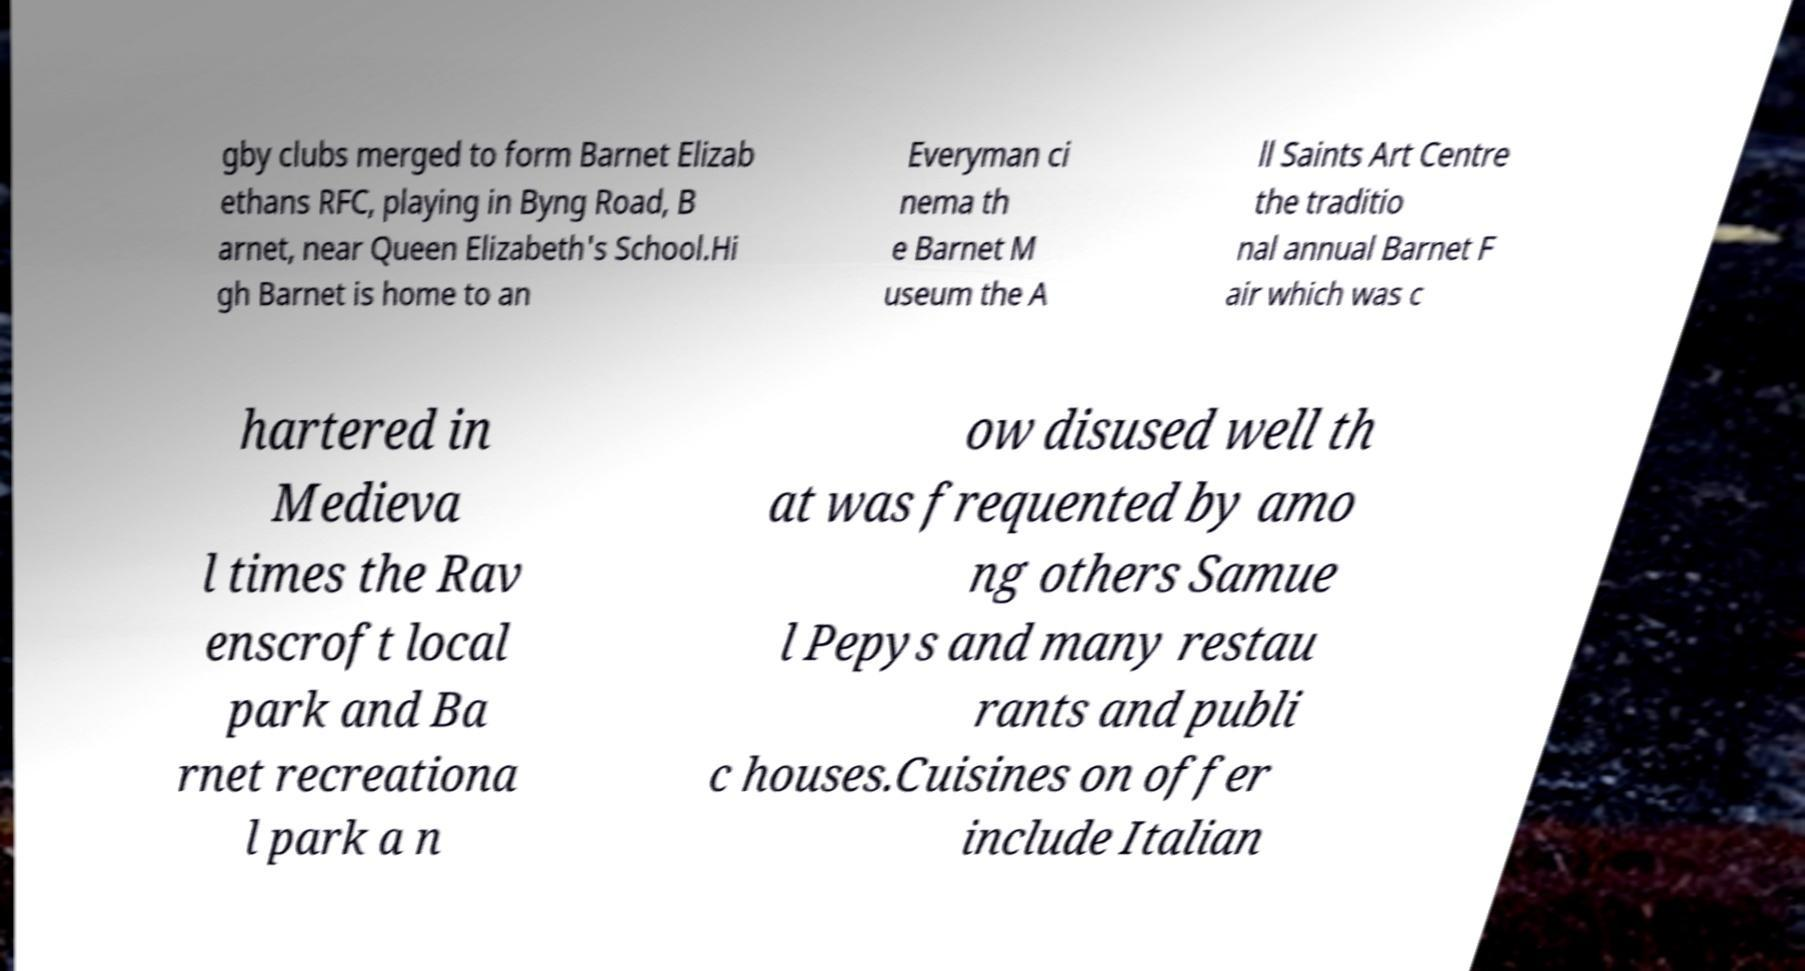Could you extract and type out the text from this image? gby clubs merged to form Barnet Elizab ethans RFC, playing in Byng Road, B arnet, near Queen Elizabeth's School.Hi gh Barnet is home to an Everyman ci nema th e Barnet M useum the A ll Saints Art Centre the traditio nal annual Barnet F air which was c hartered in Medieva l times the Rav enscroft local park and Ba rnet recreationa l park a n ow disused well th at was frequented by amo ng others Samue l Pepys and many restau rants and publi c houses.Cuisines on offer include Italian 